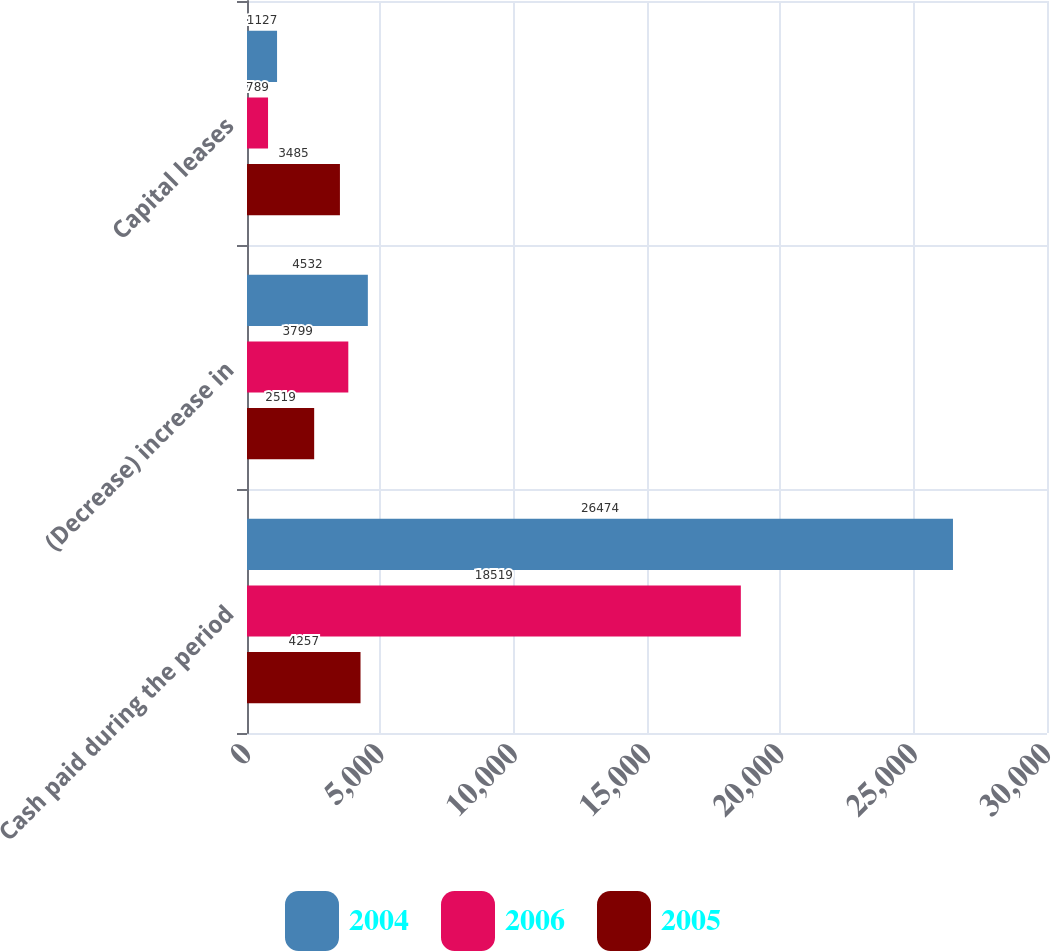Convert chart to OTSL. <chart><loc_0><loc_0><loc_500><loc_500><stacked_bar_chart><ecel><fcel>Cash paid during the period<fcel>(Decrease) increase in<fcel>Capital leases<nl><fcel>2004<fcel>26474<fcel>4532<fcel>1127<nl><fcel>2006<fcel>18519<fcel>3799<fcel>789<nl><fcel>2005<fcel>4257<fcel>2519<fcel>3485<nl></chart> 